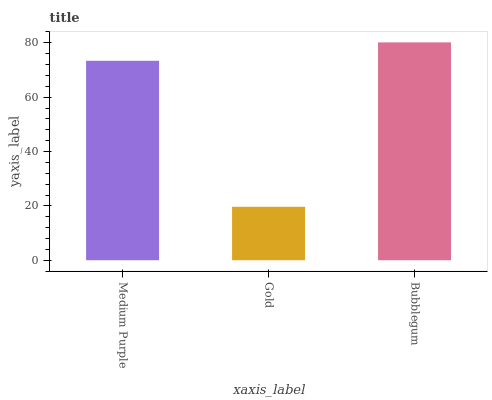Is Gold the minimum?
Answer yes or no. Yes. Is Bubblegum the maximum?
Answer yes or no. Yes. Is Bubblegum the minimum?
Answer yes or no. No. Is Gold the maximum?
Answer yes or no. No. Is Bubblegum greater than Gold?
Answer yes or no. Yes. Is Gold less than Bubblegum?
Answer yes or no. Yes. Is Gold greater than Bubblegum?
Answer yes or no. No. Is Bubblegum less than Gold?
Answer yes or no. No. Is Medium Purple the high median?
Answer yes or no. Yes. Is Medium Purple the low median?
Answer yes or no. Yes. Is Gold the high median?
Answer yes or no. No. Is Gold the low median?
Answer yes or no. No. 